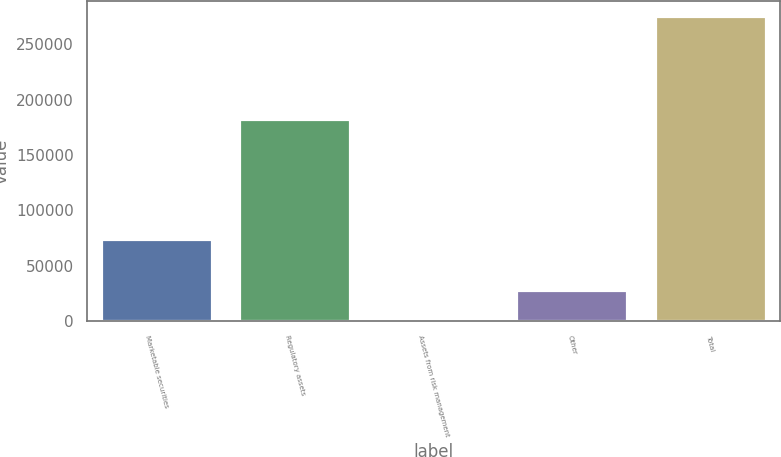<chart> <loc_0><loc_0><loc_500><loc_500><bar_chart><fcel>Marketable securities<fcel>Regulatory assets<fcel>Assets from risk management<fcel>Other<fcel>Total<nl><fcel>74200<fcel>182573<fcel>368<fcel>27879.6<fcel>275484<nl></chart> 